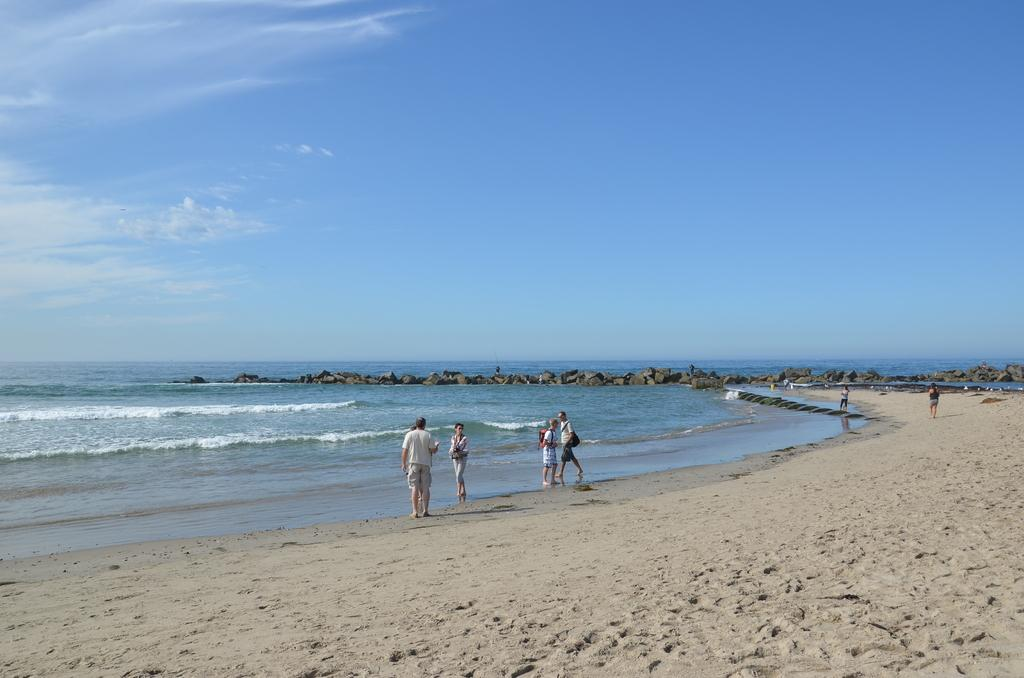What is the main setting of the image? The main setting of the image is the seashore. What natural features can be seen in the image? There are rocks visible in the image, as well as the ocean. What else is visible in the image besides the seashore and natural features? The sky is visible in the image. Are there any people present in the image? Yes, there are people on the seashore in the image. What type of tax is being discussed by the people on the seashore in the image? There is no indication in the image that the people are discussing any type of tax. Can you describe the crate that is visible in the image? There is no crate present in the image. 